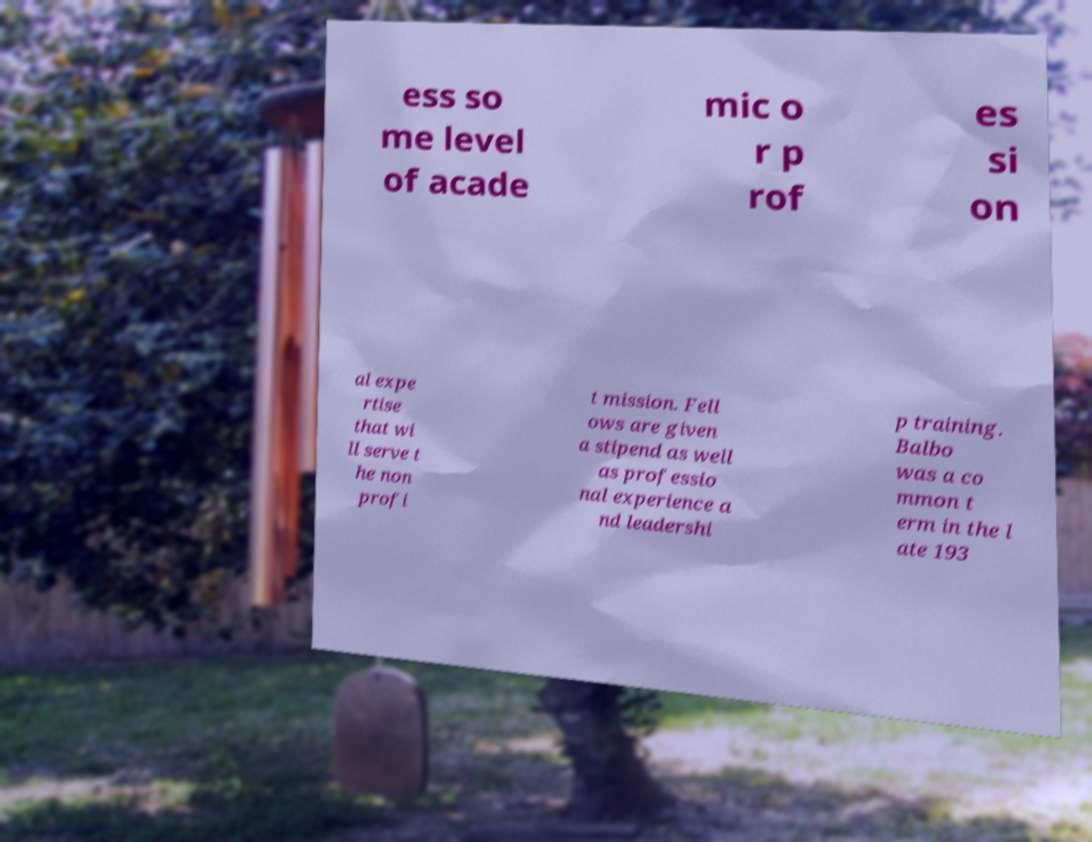Could you assist in decoding the text presented in this image and type it out clearly? ess so me level of acade mic o r p rof es si on al expe rtise that wi ll serve t he non profi t mission. Fell ows are given a stipend as well as professio nal experience a nd leadershi p training. Balbo was a co mmon t erm in the l ate 193 